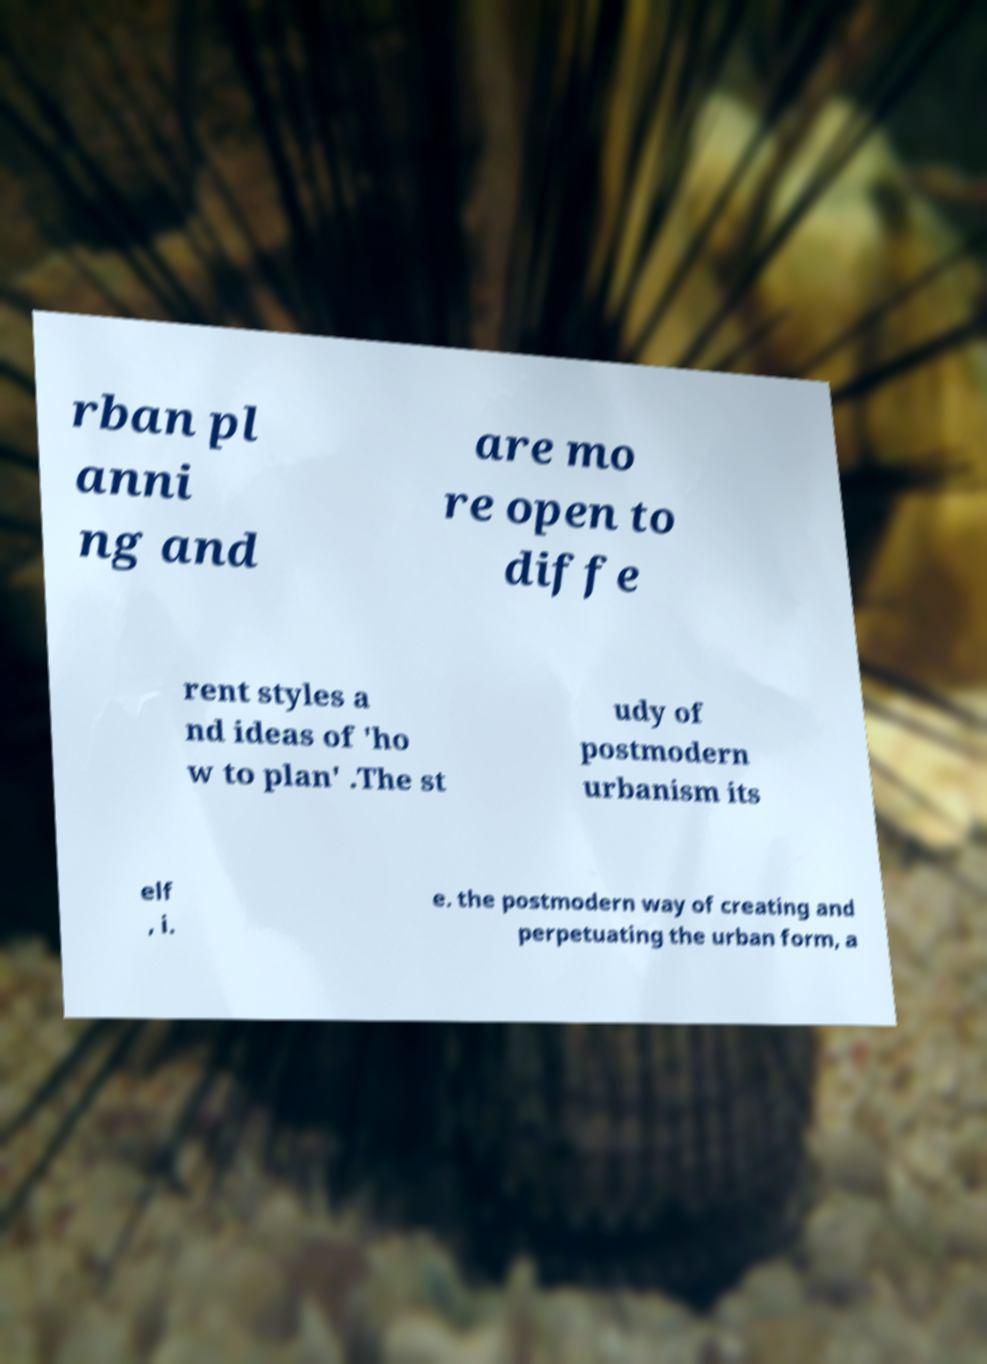Can you read and provide the text displayed in the image?This photo seems to have some interesting text. Can you extract and type it out for me? rban pl anni ng and are mo re open to diffe rent styles a nd ideas of 'ho w to plan' .The st udy of postmodern urbanism its elf , i. e. the postmodern way of creating and perpetuating the urban form, a 